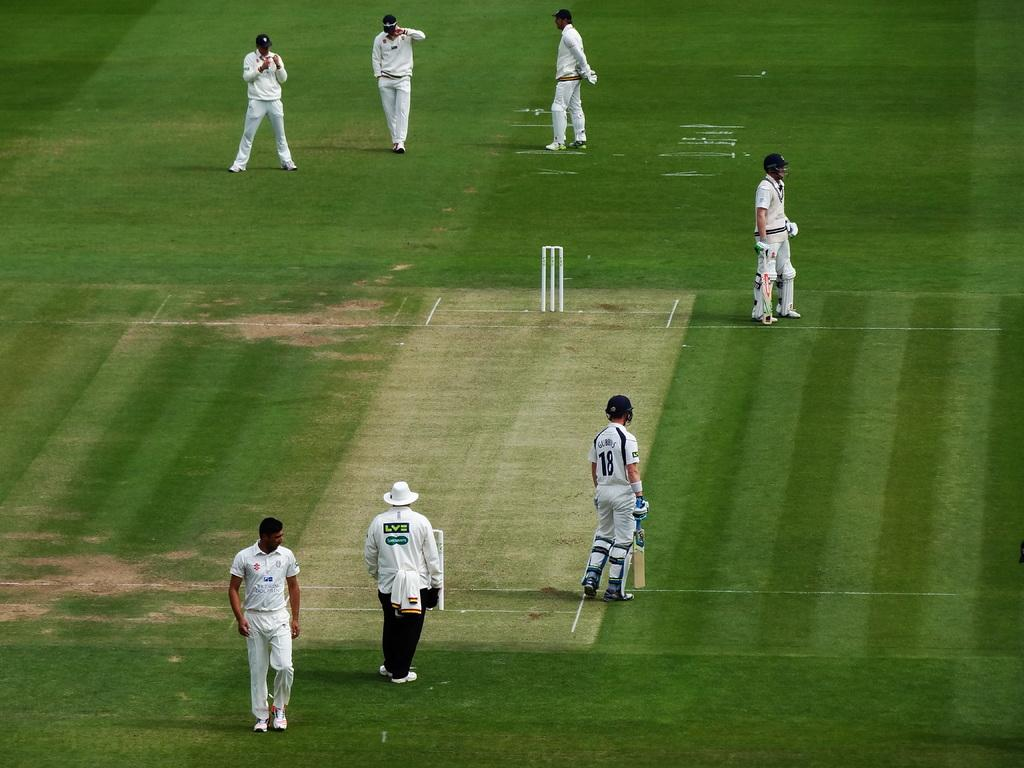<image>
Offer a succinct explanation of the picture presented. a field that has player number 18 on it 